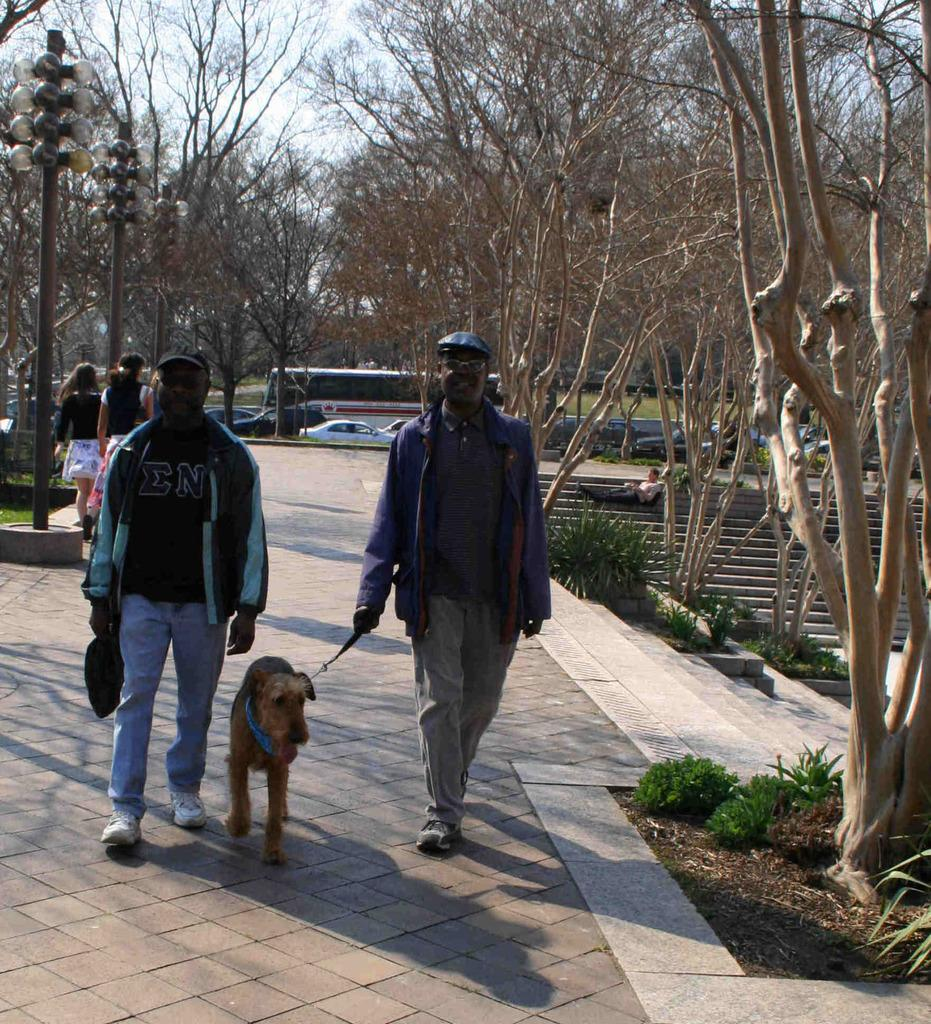What are the people in the image doing? The people in the image are walking on the road. What type of animal is present in the image? There is a dog in the image. What type of vegetation can be seen in the image? There are plants and trees in the image. What else can be seen on the road in the image? There are vehicles in the image. What is the tall, vertical object in the image? There is a pole in the image. What is visible in the background of the image? The sky is visible in the image. What type of jeans is the truck wearing in the image? There is no truck or jeans present in the image. What shape is the square in the image? There is no square present in the image. 